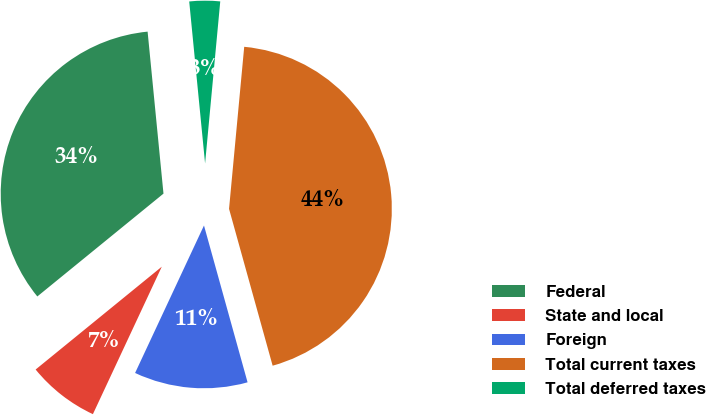Convert chart. <chart><loc_0><loc_0><loc_500><loc_500><pie_chart><fcel>Federal<fcel>State and local<fcel>Foreign<fcel>Total current taxes<fcel>Total deferred taxes<nl><fcel>34.33%<fcel>7.16%<fcel>11.27%<fcel>44.2%<fcel>3.04%<nl></chart> 